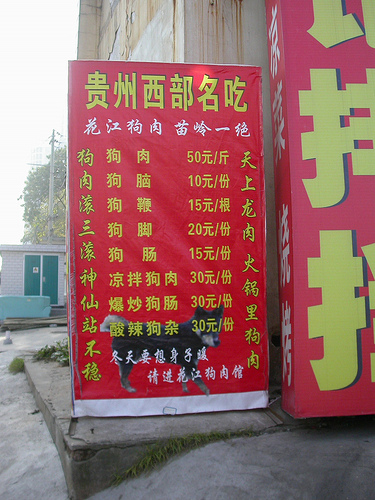<image>
Can you confirm if the dog is under the symbol? Yes. The dog is positioned underneath the symbol, with the symbol above it in the vertical space. Where is the animal in relation to the sign? Is it in the sign? Yes. The animal is contained within or inside the sign, showing a containment relationship. 